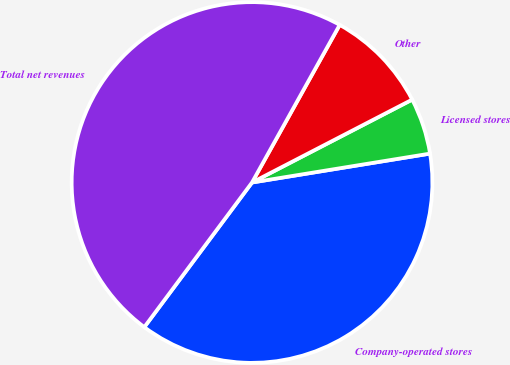Convert chart. <chart><loc_0><loc_0><loc_500><loc_500><pie_chart><fcel>Company-operated stores<fcel>Licensed stores<fcel>Other<fcel>Total net revenues<nl><fcel>37.75%<fcel>5.04%<fcel>9.32%<fcel>47.89%<nl></chart> 